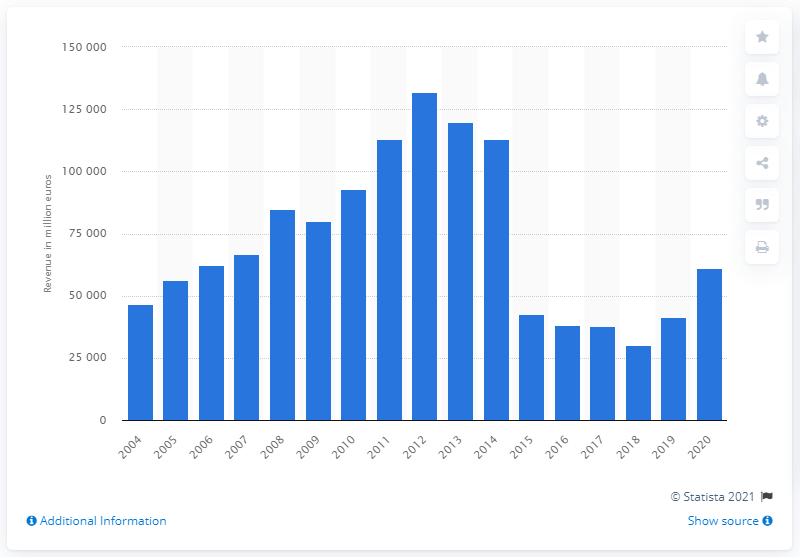Highlight a few significant elements in this photo. In 2014, E.ON reported its highest sales revenue. E.ON's annual sales revenue at the end of 2020 was approximately 609,440. 